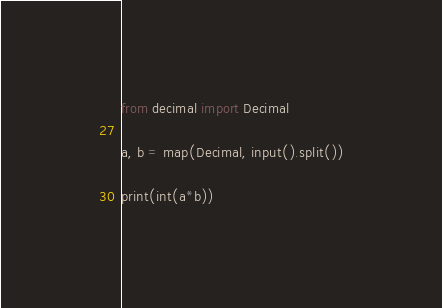<code> <loc_0><loc_0><loc_500><loc_500><_Python_>from decimal import Decimal

a, b = map(Decimal, input().split())

print(int(a*b))</code> 